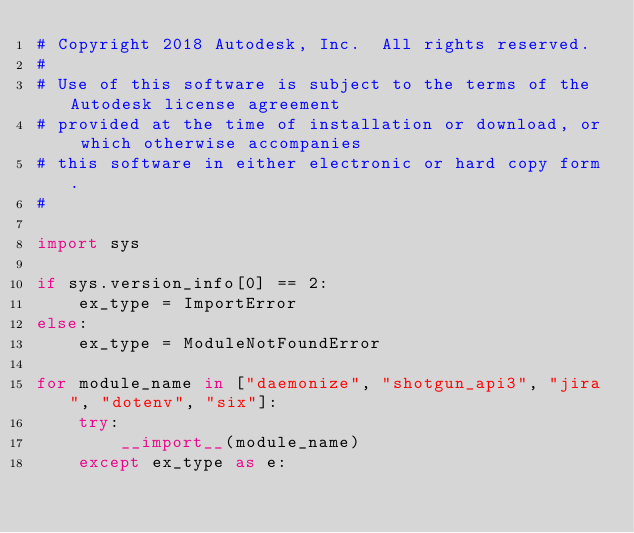Convert code to text. <code><loc_0><loc_0><loc_500><loc_500><_Python_># Copyright 2018 Autodesk, Inc.  All rights reserved.
#
# Use of this software is subject to the terms of the Autodesk license agreement
# provided at the time of installation or download, or which otherwise accompanies
# this software in either electronic or hard copy form.
#

import sys

if sys.version_info[0] == 2:
    ex_type = ImportError
else:
    ex_type = ModuleNotFoundError

for module_name in ["daemonize", "shotgun_api3", "jira", "dotenv", "six"]:
    try:
        __import__(module_name)
    except ex_type as e:</code> 